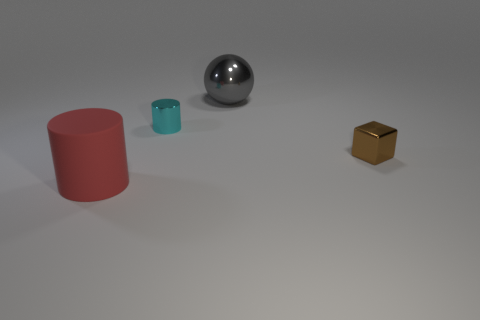Add 4 tiny cyan metal cylinders. How many objects exist? 8 Subtract all spheres. How many objects are left? 3 Subtract all red cylinders. How many cylinders are left? 1 Subtract all cyan cubes. Subtract all gray balls. How many cubes are left? 1 Subtract all gray spheres. How many cyan cylinders are left? 1 Subtract all yellow balls. Subtract all large gray metallic objects. How many objects are left? 3 Add 1 brown shiny blocks. How many brown shiny blocks are left? 2 Add 1 red things. How many red things exist? 2 Subtract 0 blue blocks. How many objects are left? 4 